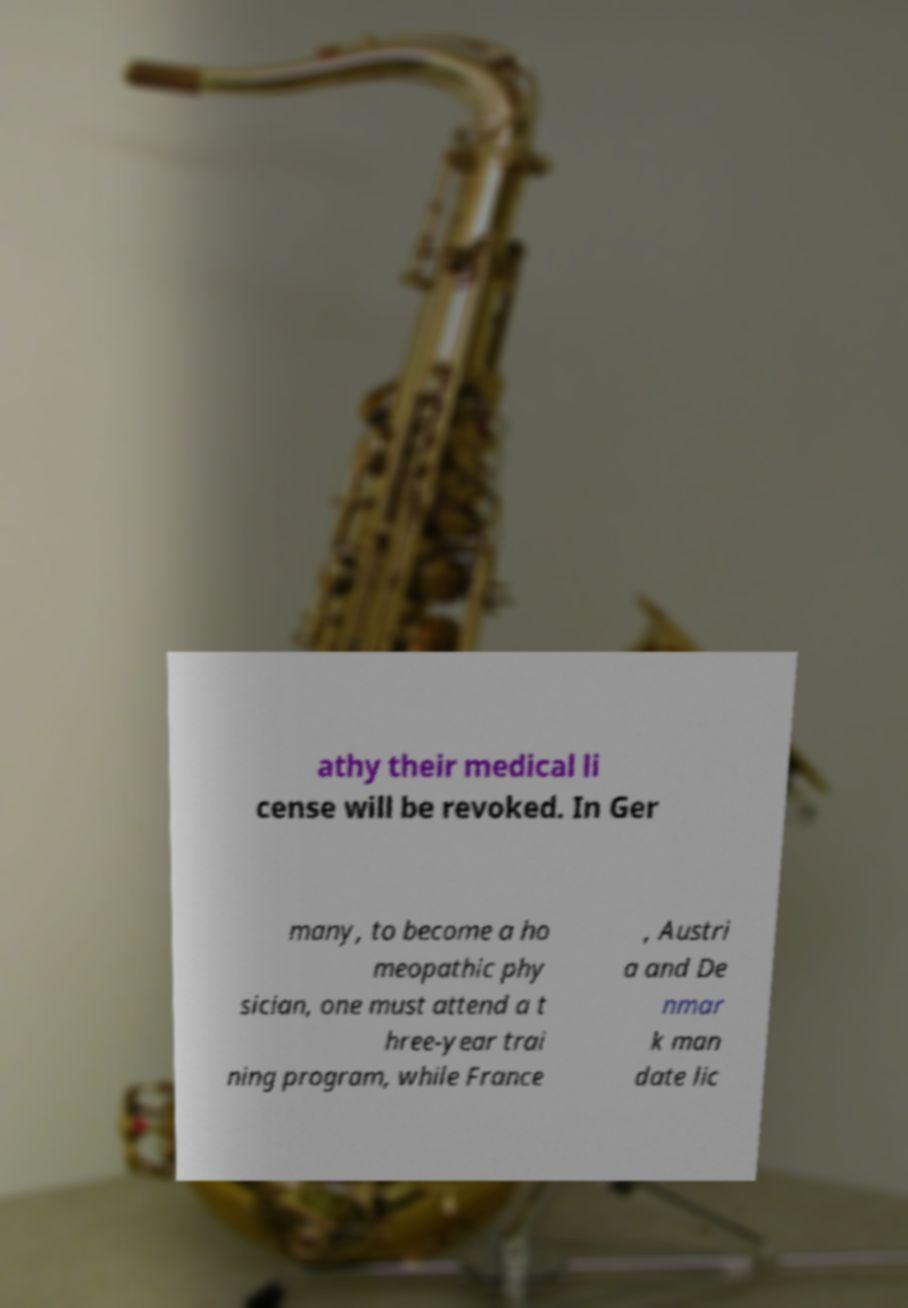There's text embedded in this image that I need extracted. Can you transcribe it verbatim? athy their medical li cense will be revoked. In Ger many, to become a ho meopathic phy sician, one must attend a t hree-year trai ning program, while France , Austri a and De nmar k man date lic 